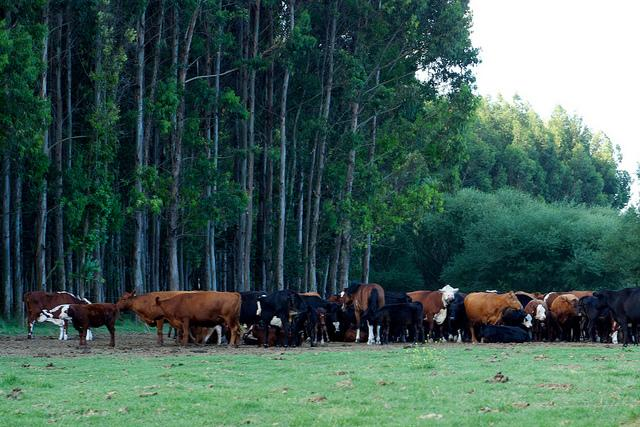What animal are these? cows 